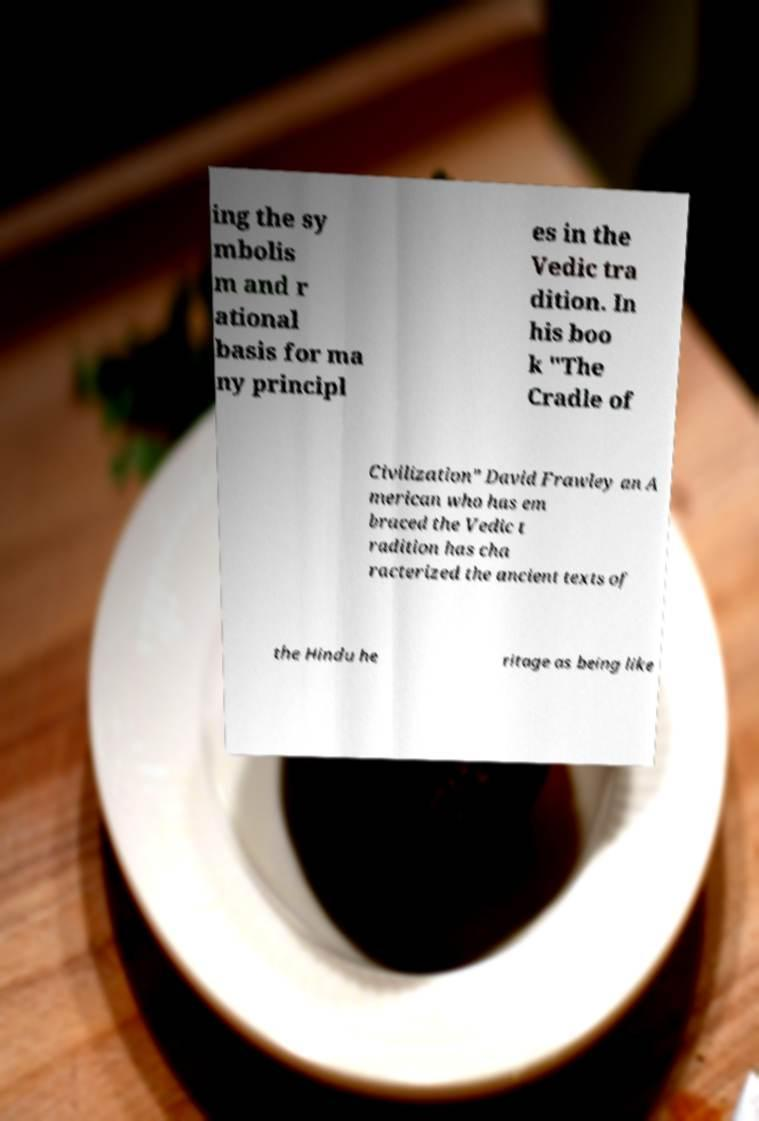Could you assist in decoding the text presented in this image and type it out clearly? ing the sy mbolis m and r ational basis for ma ny principl es in the Vedic tra dition. In his boo k "The Cradle of Civilization" David Frawley an A merican who has em braced the Vedic t radition has cha racterized the ancient texts of the Hindu he ritage as being like 